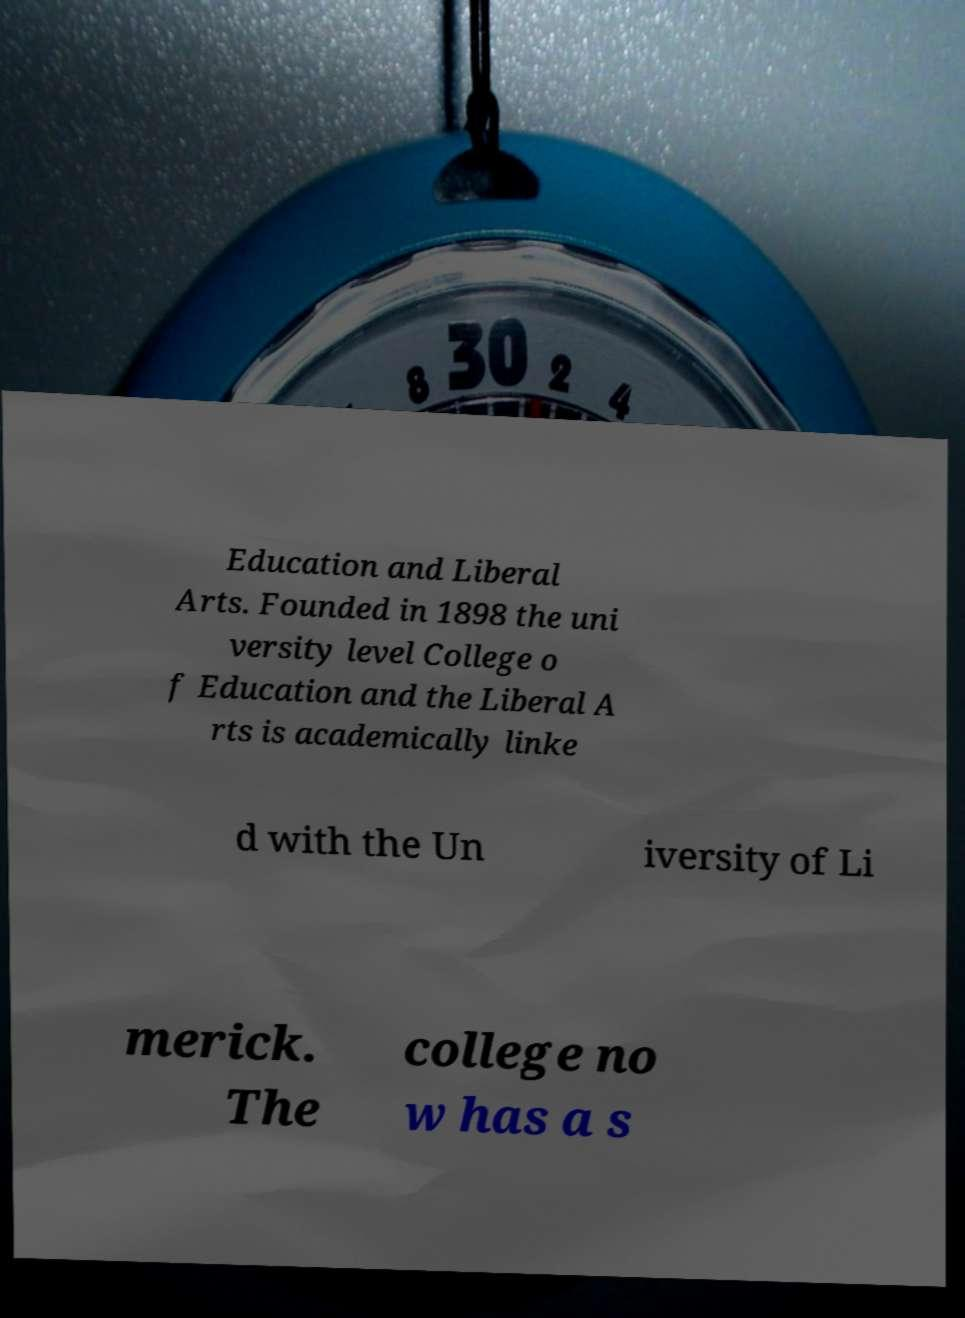I need the written content from this picture converted into text. Can you do that? Education and Liberal Arts. Founded in 1898 the uni versity level College o f Education and the Liberal A rts is academically linke d with the Un iversity of Li merick. The college no w has a s 